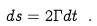<formula> <loc_0><loc_0><loc_500><loc_500>d s = 2 \Gamma d t \ .</formula> 